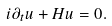Convert formula to latex. <formula><loc_0><loc_0><loc_500><loc_500>i \partial _ { t } u + H u = 0 .</formula> 